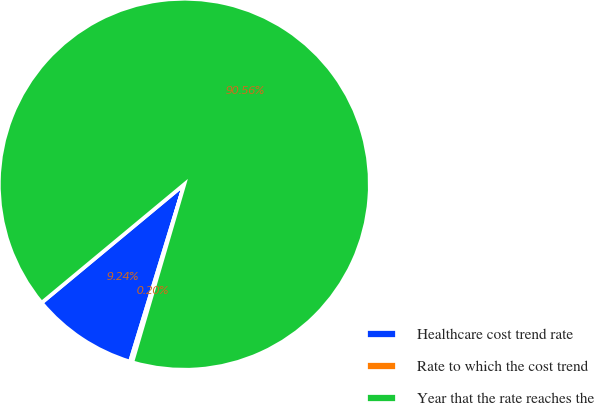Convert chart to OTSL. <chart><loc_0><loc_0><loc_500><loc_500><pie_chart><fcel>Healthcare cost trend rate<fcel>Rate to which the cost trend<fcel>Year that the rate reaches the<nl><fcel>9.24%<fcel>0.2%<fcel>90.56%<nl></chart> 